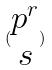<formula> <loc_0><loc_0><loc_500><loc_500>( \begin{matrix} p ^ { r } \\ s \end{matrix} )</formula> 